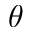<formula> <loc_0><loc_0><loc_500><loc_500>\theta</formula> 